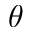<formula> <loc_0><loc_0><loc_500><loc_500>\theta</formula> 